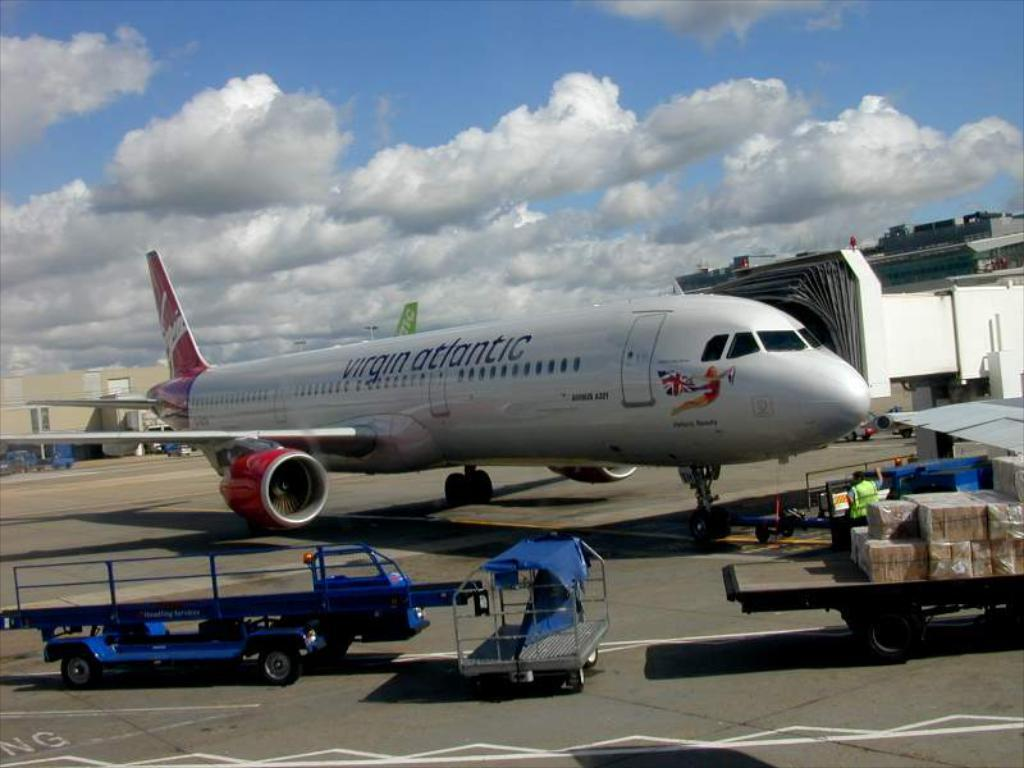What is the main subject of the image? The main subject of the image is an airplane. What else can be seen on the ground in the image? There are vehicles on the ground in the image. What type of structures are visible in the image? There are buildings in the image. What additional objects can be found in the image? There are cartoon boxes in the image. What is visible in the background of the image? The sky is visible in the background of the image. Can you describe the sky in the image? Clouds are present in the sky. How many beetles can be seen crawling on the airplane in the image? There are no beetles present in the image. What is the mass of the number 7 in the image? There is no number 7 or any reference to mass in the image. 